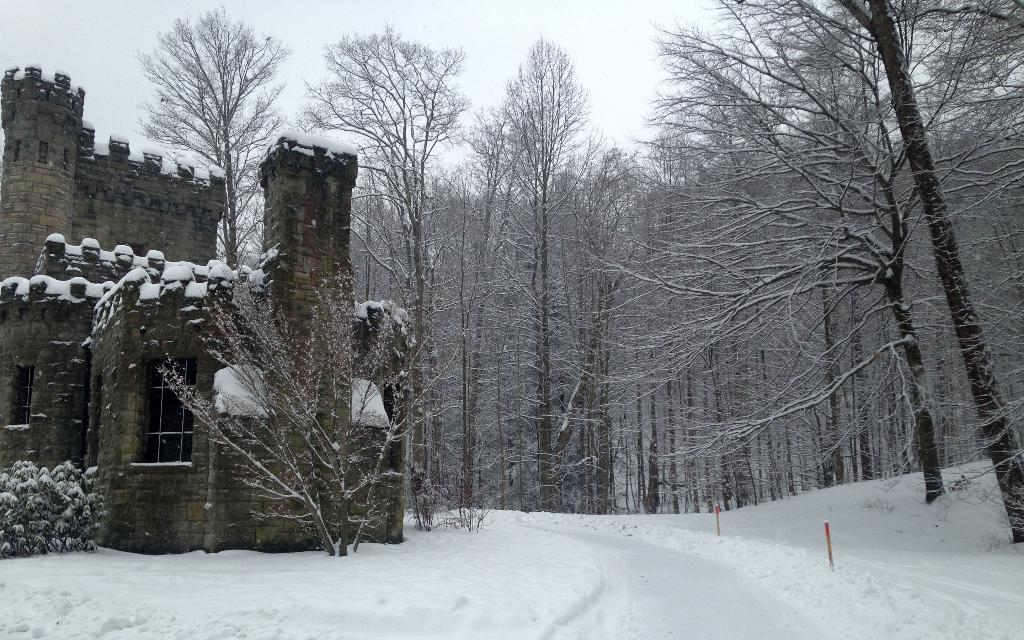What type of plant can be seen in the image? There is a tree in the image. What type of structure is visible in the image? There is a house in the image. What can be seen in the background of the image? There are trees in the background of the image. What type of engine can be seen powering the tree in the image? There is no engine present in the image, and trees do not require engines to function. 